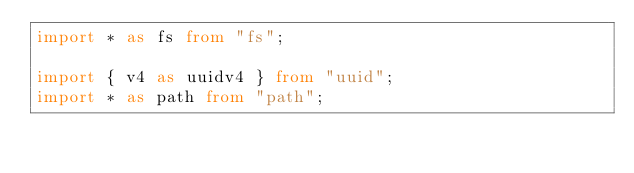<code> <loc_0><loc_0><loc_500><loc_500><_TypeScript_>import * as fs from "fs";

import { v4 as uuidv4 } from "uuid";
import * as path from "path";
</code> 